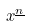<formula> <loc_0><loc_0><loc_500><loc_500>x ^ { \underline { n } }</formula> 